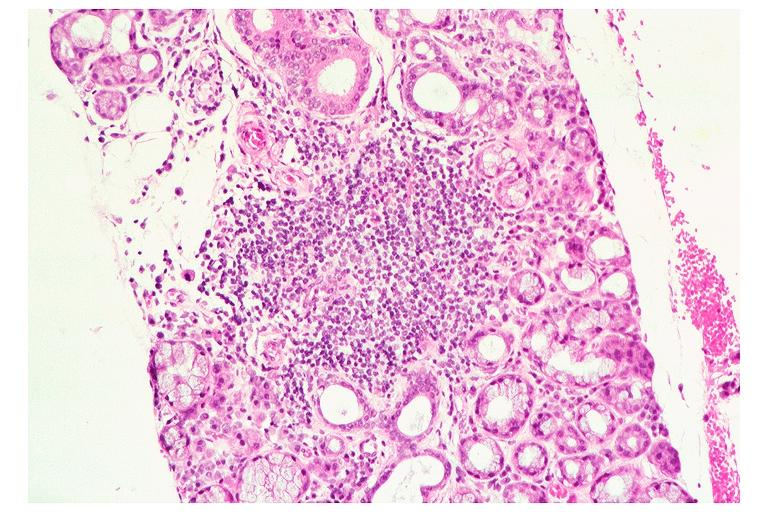does this image show sjogrens syndrome?
Answer the question using a single word or phrase. Yes 